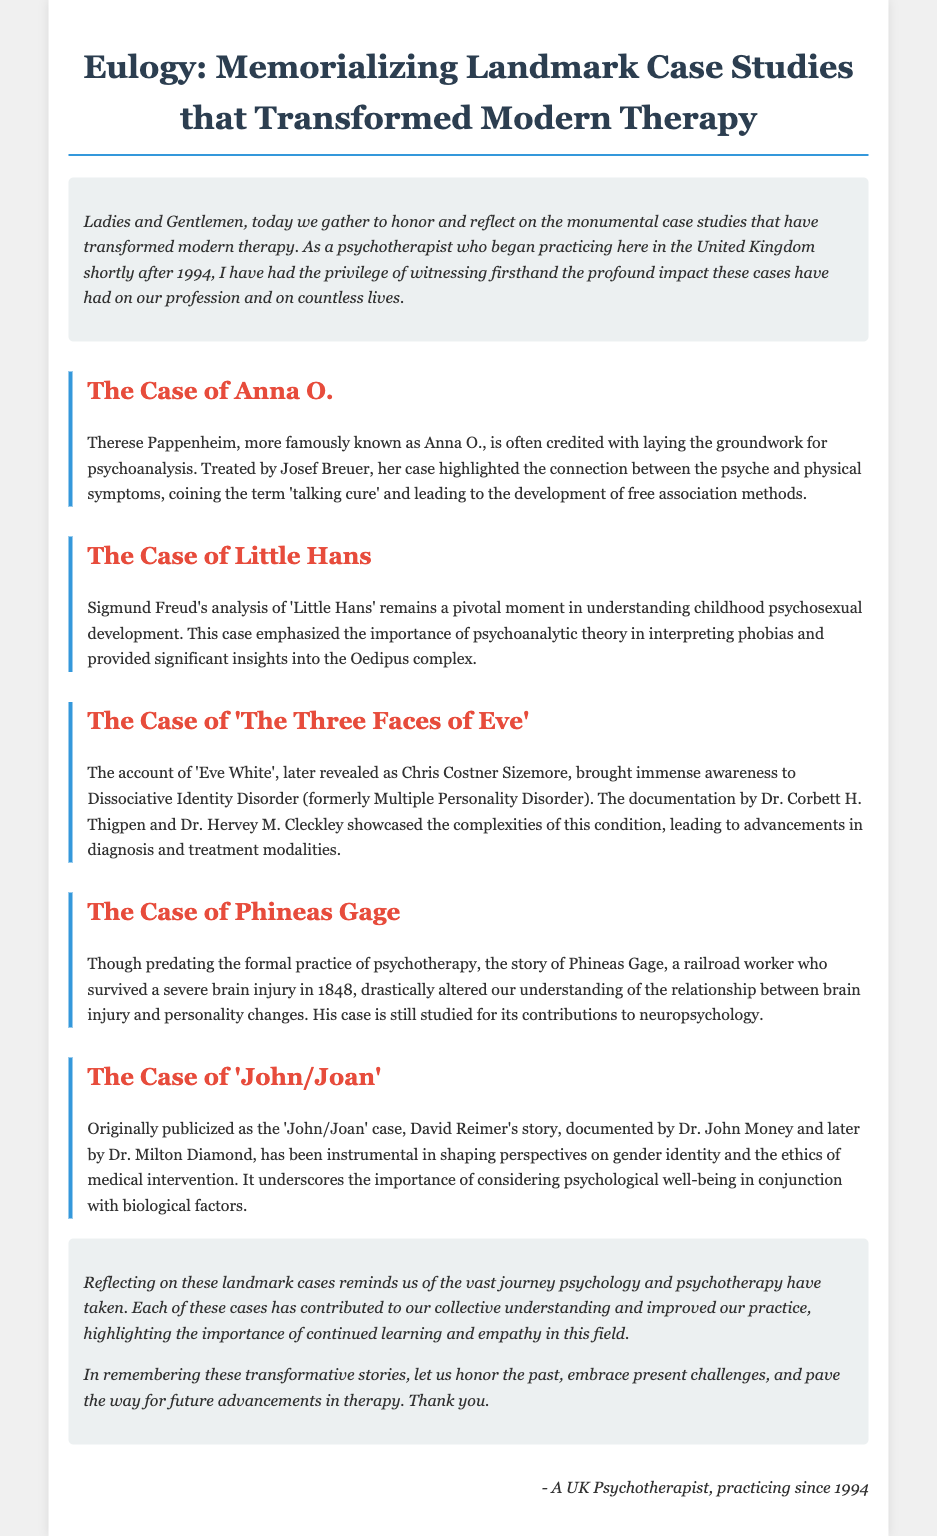What is the title of the document? The title clearly states the purpose and theme of the document.
Answer: Eulogy: Memorializing Landmark Case Studies that Transformed Modern Therapy Who treated Anna O.? The document specifies the therapist associated with Anna O.'s case.
Answer: Josef Breuer What condition did Eve White have? The eulogy identifies the disorder attributed to Chris Costner Sizemore.
Answer: Dissociative Identity Disorder What year did Phineas Gage's accident occur? The document provides the year of the accident that is significant to the case study.
Answer: 1848 What major psychological concept is associated with Little Hans? The document highlights a key idea stemming from Freud's analysis of Little Hans.
Answer: Oedipus complex How did the 'John/Joan' case influence perceptions? The eulogy explains the implications of the 'John/Joan' case on psychology and treatment approaches.
Answer: Gender identity What is the significance of the case studies mentioned? The conclusion reflects on the importance of the collective impact of these cases on therapy.
Answer: Transformed modern therapy In what style is the introduction presented? The document describes the tone and presentation style of the introductory section on landmark cases.
Answer: Italic 